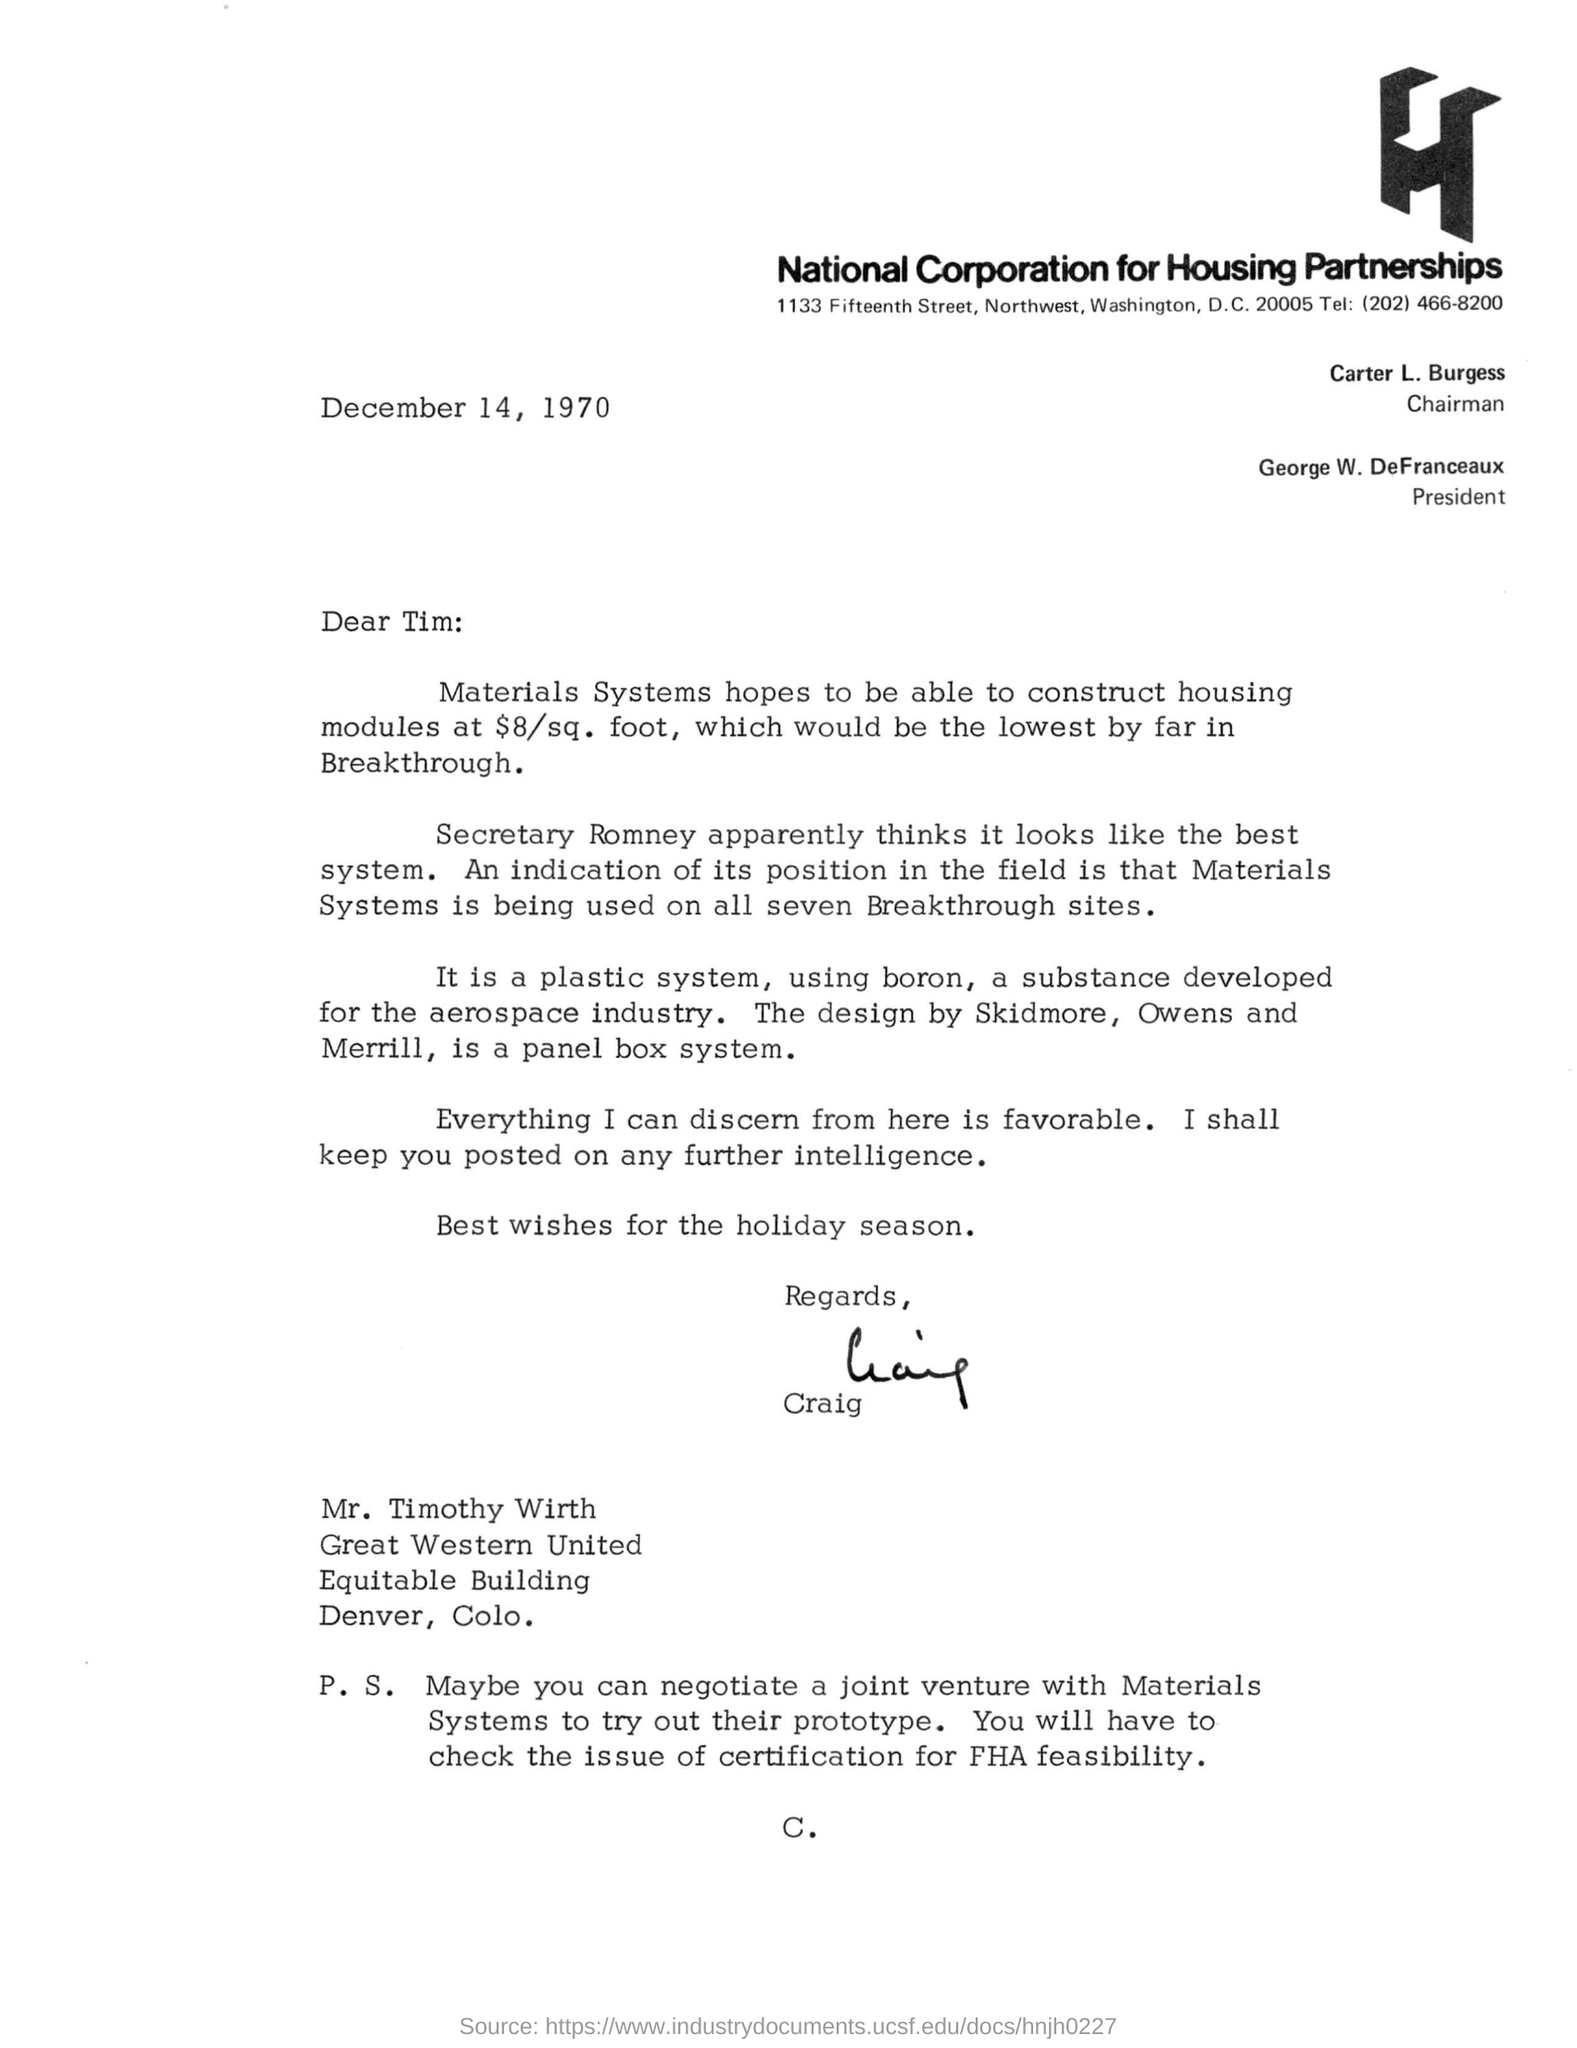On which date this letter is written ?
Give a very brief answer. December 14, 1970. To whom this letter was written ?
Provide a succinct answer. Mr. Timothy Wirth. Who is the chairman of national corporation for housing partnerships ?
Offer a terse response. Carter L. Burgess. Who is the president of national corporation for housing partnerships ?
Offer a very short reply. George W. DeFranceaux. Who's sign was there in the letter ?
Keep it short and to the point. Craig. Who had written this letter ?
Provide a short and direct response. Craig. 